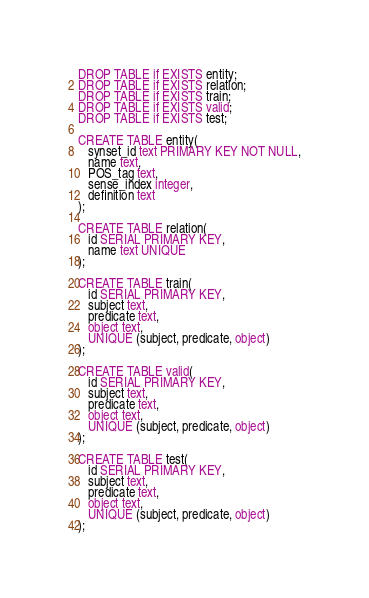<code> <loc_0><loc_0><loc_500><loc_500><_SQL_>DROP TABLE if EXISTS entity;
DROP TABLE if EXISTS relation;
DROP TABLE if EXISTS train;
DROP TABLE if EXISTS valid;
DROP TABLE if EXISTS test;

CREATE TABLE entity(
   synset_id text PRIMARY KEY NOT NULL,
   name text,
   POS_tag text,
   sense_index integer,
   definition text
);

CREATE TABLE relation(
   id SERIAL PRIMARY KEY,
   name text UNIQUE
);

CREATE TABLE train(
   id SERIAL PRIMARY KEY,
   subject text,
   predicate text,
   object text,
   UNIQUE (subject, predicate, object)
);

CREATE TABLE valid(
   id SERIAL PRIMARY KEY,
   subject text,
   predicate text,
   object text,
   UNIQUE (subject, predicate, object)
);

CREATE TABLE test(
   id SERIAL PRIMARY KEY,
   subject text,
   predicate text,
   object text,
   UNIQUE (subject, predicate, object)
);</code> 